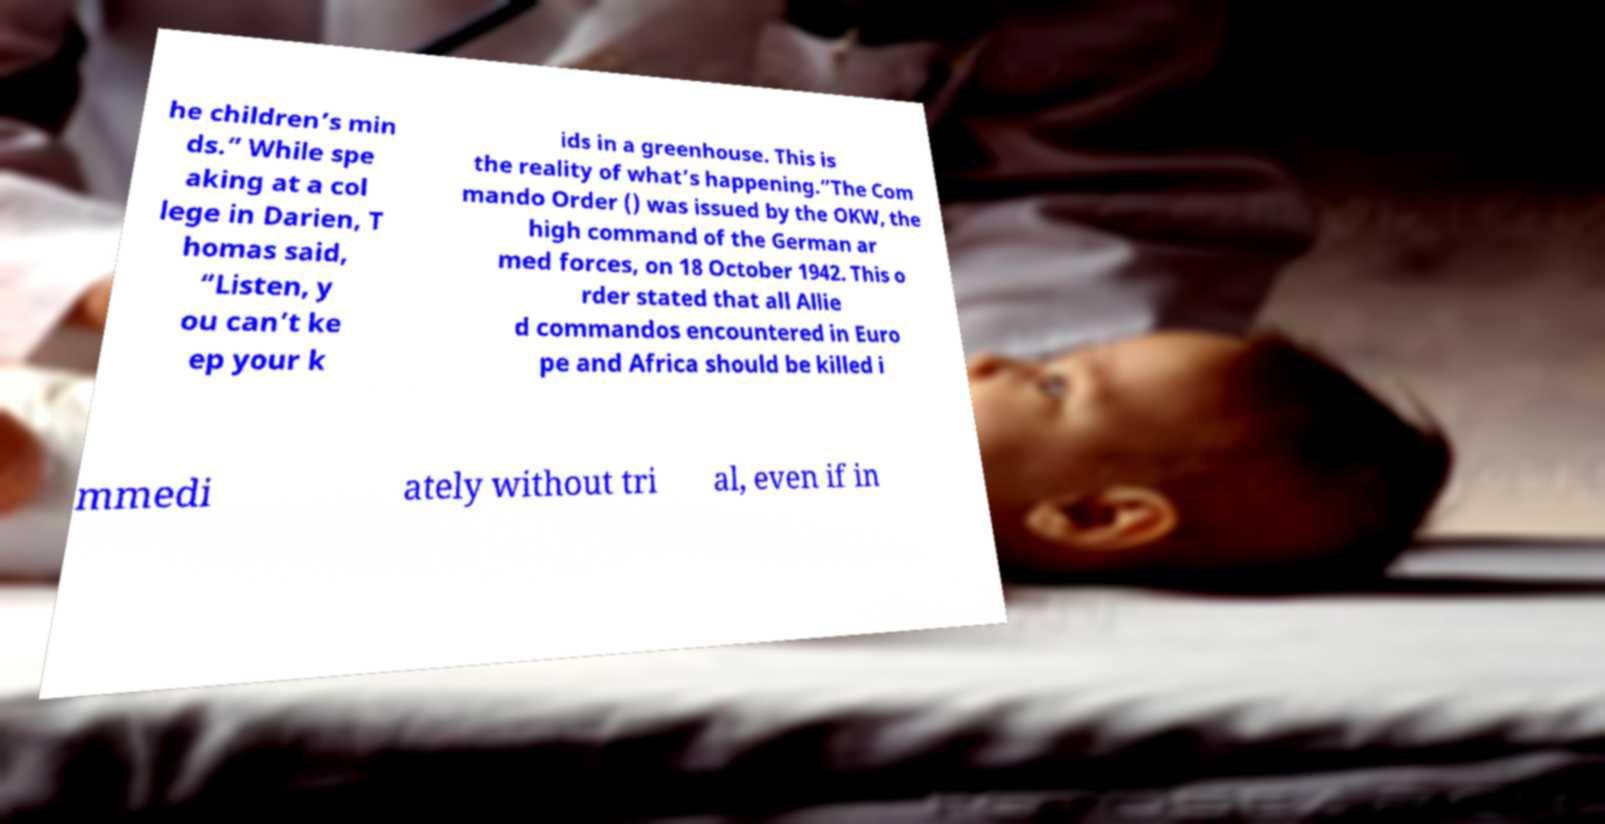Could you assist in decoding the text presented in this image and type it out clearly? he children’s min ds.” While spe aking at a col lege in Darien, T homas said, “Listen, y ou can’t ke ep your k ids in a greenhouse. This is the reality of what’s happening.”The Com mando Order () was issued by the OKW, the high command of the German ar med forces, on 18 October 1942. This o rder stated that all Allie d commandos encountered in Euro pe and Africa should be killed i mmedi ately without tri al, even if in 